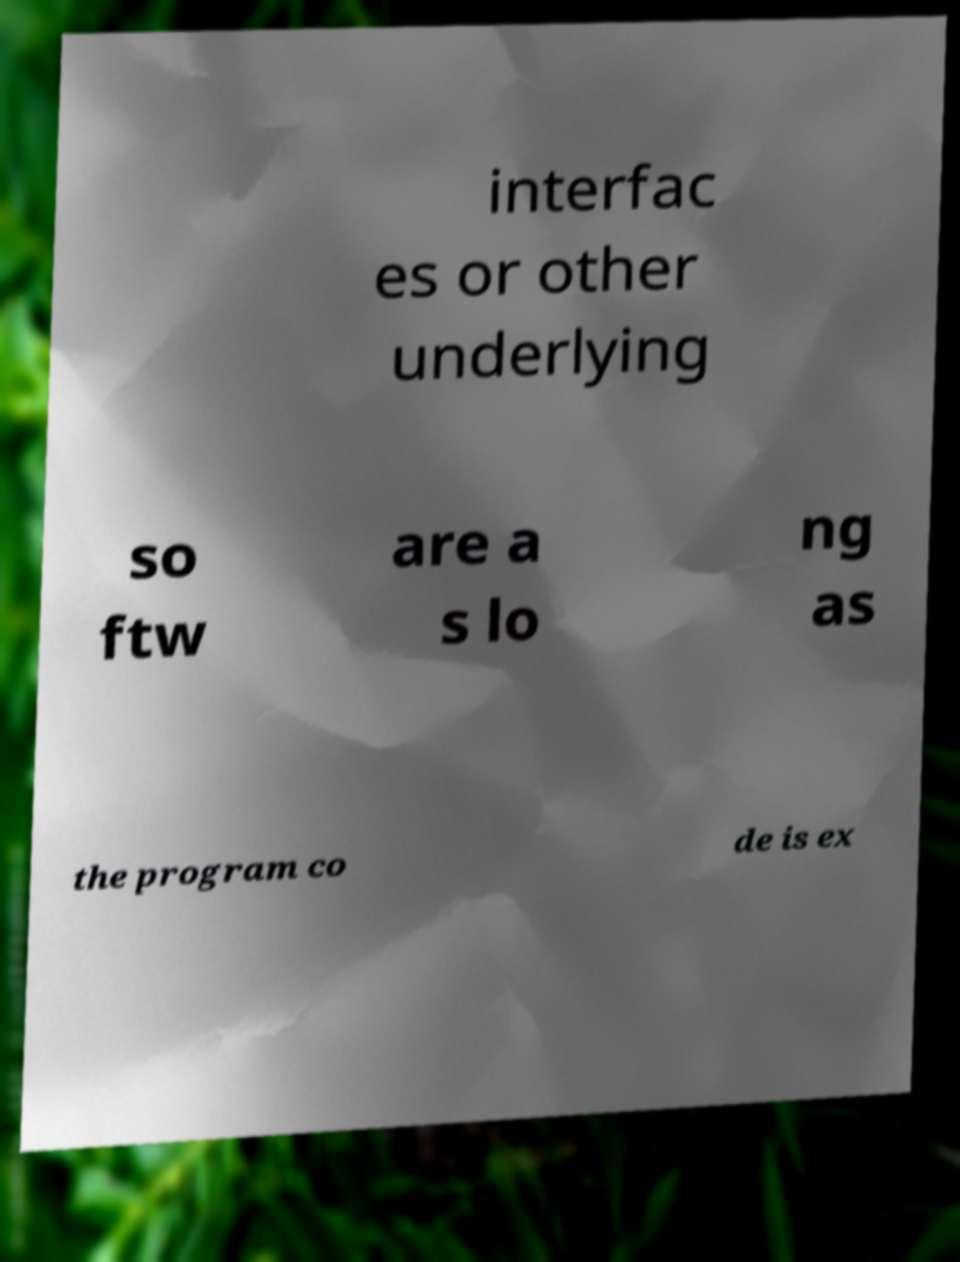Could you extract and type out the text from this image? interfac es or other underlying so ftw are a s lo ng as the program co de is ex 